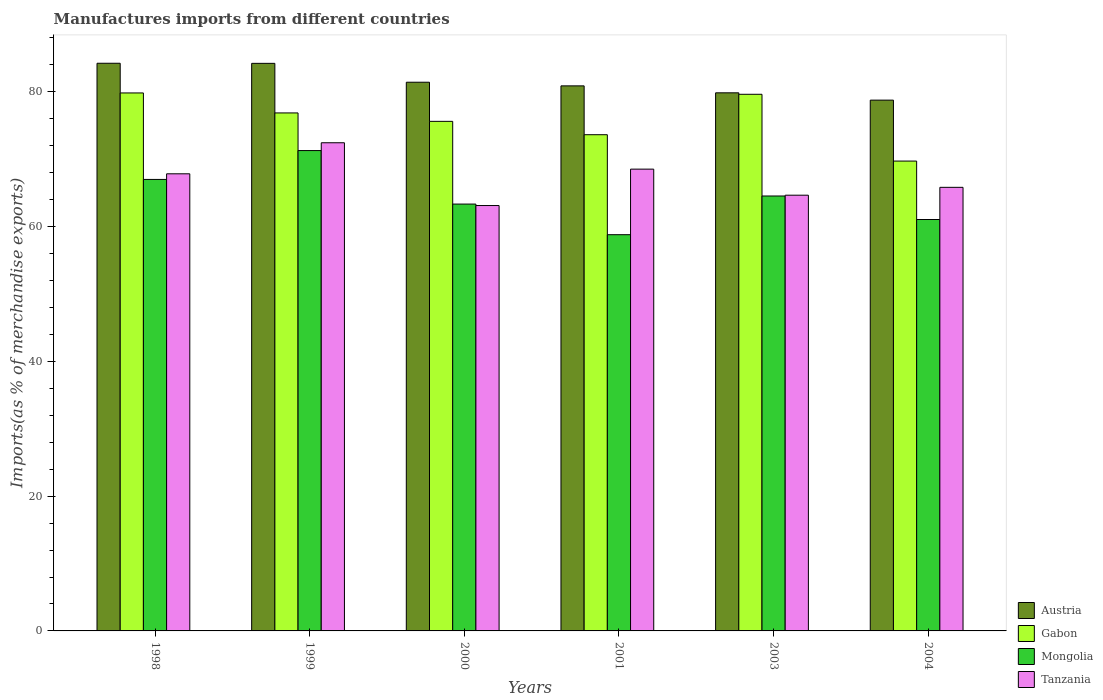How many groups of bars are there?
Give a very brief answer. 6. Are the number of bars on each tick of the X-axis equal?
Make the answer very short. Yes. How many bars are there on the 5th tick from the left?
Offer a very short reply. 4. In how many cases, is the number of bars for a given year not equal to the number of legend labels?
Ensure brevity in your answer.  0. What is the percentage of imports to different countries in Gabon in 2003?
Provide a short and direct response. 79.64. Across all years, what is the maximum percentage of imports to different countries in Austria?
Your response must be concise. 84.25. Across all years, what is the minimum percentage of imports to different countries in Austria?
Your answer should be very brief. 78.77. In which year was the percentage of imports to different countries in Mongolia maximum?
Your response must be concise. 1999. In which year was the percentage of imports to different countries in Austria minimum?
Give a very brief answer. 2004. What is the total percentage of imports to different countries in Mongolia in the graph?
Make the answer very short. 386.05. What is the difference between the percentage of imports to different countries in Mongolia in 2000 and that in 2003?
Offer a very short reply. -1.2. What is the difference between the percentage of imports to different countries in Gabon in 2000 and the percentage of imports to different countries in Mongolia in 2004?
Provide a succinct answer. 14.57. What is the average percentage of imports to different countries in Austria per year?
Your answer should be compact. 81.57. In the year 2000, what is the difference between the percentage of imports to different countries in Tanzania and percentage of imports to different countries in Gabon?
Your answer should be very brief. -12.5. In how many years, is the percentage of imports to different countries in Tanzania greater than 64 %?
Your answer should be compact. 5. What is the ratio of the percentage of imports to different countries in Tanzania in 1999 to that in 2001?
Offer a very short reply. 1.06. Is the difference between the percentage of imports to different countries in Tanzania in 1999 and 2001 greater than the difference between the percentage of imports to different countries in Gabon in 1999 and 2001?
Offer a very short reply. Yes. What is the difference between the highest and the second highest percentage of imports to different countries in Mongolia?
Offer a very short reply. 4.28. What is the difference between the highest and the lowest percentage of imports to different countries in Gabon?
Your answer should be compact. 10.11. In how many years, is the percentage of imports to different countries in Gabon greater than the average percentage of imports to different countries in Gabon taken over all years?
Make the answer very short. 3. What does the 3rd bar from the left in 1998 represents?
Your answer should be very brief. Mongolia. What does the 1st bar from the right in 1998 represents?
Offer a very short reply. Tanzania. How many bars are there?
Give a very brief answer. 24. Are all the bars in the graph horizontal?
Offer a very short reply. No. How many years are there in the graph?
Make the answer very short. 6. What is the difference between two consecutive major ticks on the Y-axis?
Offer a very short reply. 20. Are the values on the major ticks of Y-axis written in scientific E-notation?
Provide a succinct answer. No. Does the graph contain grids?
Offer a terse response. No. Where does the legend appear in the graph?
Ensure brevity in your answer.  Bottom right. What is the title of the graph?
Your response must be concise. Manufactures imports from different countries. Does "Latin America(developing only)" appear as one of the legend labels in the graph?
Provide a short and direct response. No. What is the label or title of the X-axis?
Your response must be concise. Years. What is the label or title of the Y-axis?
Provide a succinct answer. Imports(as % of merchandise exports). What is the Imports(as % of merchandise exports) in Austria in 1998?
Your response must be concise. 84.25. What is the Imports(as % of merchandise exports) in Gabon in 1998?
Your answer should be very brief. 79.84. What is the Imports(as % of merchandise exports) of Mongolia in 1998?
Ensure brevity in your answer.  67.01. What is the Imports(as % of merchandise exports) of Tanzania in 1998?
Make the answer very short. 67.84. What is the Imports(as % of merchandise exports) of Austria in 1999?
Your response must be concise. 84.23. What is the Imports(as % of merchandise exports) of Gabon in 1999?
Ensure brevity in your answer.  76.87. What is the Imports(as % of merchandise exports) in Mongolia in 1999?
Offer a terse response. 71.29. What is the Imports(as % of merchandise exports) in Tanzania in 1999?
Make the answer very short. 72.45. What is the Imports(as % of merchandise exports) of Austria in 2000?
Provide a succinct answer. 81.43. What is the Imports(as % of merchandise exports) of Gabon in 2000?
Your answer should be compact. 75.62. What is the Imports(as % of merchandise exports) in Mongolia in 2000?
Your answer should be very brief. 63.35. What is the Imports(as % of merchandise exports) of Tanzania in 2000?
Your answer should be compact. 63.13. What is the Imports(as % of merchandise exports) of Austria in 2001?
Make the answer very short. 80.89. What is the Imports(as % of merchandise exports) of Gabon in 2001?
Your answer should be very brief. 73.64. What is the Imports(as % of merchandise exports) of Mongolia in 2001?
Your response must be concise. 58.8. What is the Imports(as % of merchandise exports) of Tanzania in 2001?
Provide a short and direct response. 68.53. What is the Imports(as % of merchandise exports) of Austria in 2003?
Your response must be concise. 79.86. What is the Imports(as % of merchandise exports) of Gabon in 2003?
Provide a succinct answer. 79.64. What is the Imports(as % of merchandise exports) of Mongolia in 2003?
Your answer should be very brief. 64.55. What is the Imports(as % of merchandise exports) of Tanzania in 2003?
Ensure brevity in your answer.  64.66. What is the Imports(as % of merchandise exports) of Austria in 2004?
Keep it short and to the point. 78.77. What is the Imports(as % of merchandise exports) in Gabon in 2004?
Offer a very short reply. 69.73. What is the Imports(as % of merchandise exports) of Mongolia in 2004?
Ensure brevity in your answer.  61.06. What is the Imports(as % of merchandise exports) in Tanzania in 2004?
Your answer should be very brief. 65.83. Across all years, what is the maximum Imports(as % of merchandise exports) in Austria?
Your response must be concise. 84.25. Across all years, what is the maximum Imports(as % of merchandise exports) of Gabon?
Your answer should be very brief. 79.84. Across all years, what is the maximum Imports(as % of merchandise exports) in Mongolia?
Provide a succinct answer. 71.29. Across all years, what is the maximum Imports(as % of merchandise exports) in Tanzania?
Provide a succinct answer. 72.45. Across all years, what is the minimum Imports(as % of merchandise exports) in Austria?
Make the answer very short. 78.77. Across all years, what is the minimum Imports(as % of merchandise exports) of Gabon?
Offer a very short reply. 69.73. Across all years, what is the minimum Imports(as % of merchandise exports) of Mongolia?
Your response must be concise. 58.8. Across all years, what is the minimum Imports(as % of merchandise exports) of Tanzania?
Make the answer very short. 63.13. What is the total Imports(as % of merchandise exports) of Austria in the graph?
Provide a short and direct response. 489.43. What is the total Imports(as % of merchandise exports) of Gabon in the graph?
Provide a succinct answer. 455.35. What is the total Imports(as % of merchandise exports) in Mongolia in the graph?
Keep it short and to the point. 386.05. What is the total Imports(as % of merchandise exports) in Tanzania in the graph?
Provide a short and direct response. 402.45. What is the difference between the Imports(as % of merchandise exports) of Austria in 1998 and that in 1999?
Your answer should be compact. 0.01. What is the difference between the Imports(as % of merchandise exports) in Gabon in 1998 and that in 1999?
Your answer should be compact. 2.97. What is the difference between the Imports(as % of merchandise exports) in Mongolia in 1998 and that in 1999?
Your response must be concise. -4.28. What is the difference between the Imports(as % of merchandise exports) in Tanzania in 1998 and that in 1999?
Your response must be concise. -4.61. What is the difference between the Imports(as % of merchandise exports) in Austria in 1998 and that in 2000?
Provide a succinct answer. 2.81. What is the difference between the Imports(as % of merchandise exports) of Gabon in 1998 and that in 2000?
Ensure brevity in your answer.  4.22. What is the difference between the Imports(as % of merchandise exports) of Mongolia in 1998 and that in 2000?
Offer a terse response. 3.66. What is the difference between the Imports(as % of merchandise exports) of Tanzania in 1998 and that in 2000?
Offer a very short reply. 4.71. What is the difference between the Imports(as % of merchandise exports) in Austria in 1998 and that in 2001?
Your answer should be very brief. 3.36. What is the difference between the Imports(as % of merchandise exports) in Gabon in 1998 and that in 2001?
Offer a terse response. 6.2. What is the difference between the Imports(as % of merchandise exports) of Mongolia in 1998 and that in 2001?
Provide a short and direct response. 8.2. What is the difference between the Imports(as % of merchandise exports) in Tanzania in 1998 and that in 2001?
Provide a succinct answer. -0.69. What is the difference between the Imports(as % of merchandise exports) of Austria in 1998 and that in 2003?
Offer a very short reply. 4.39. What is the difference between the Imports(as % of merchandise exports) in Gabon in 1998 and that in 2003?
Your answer should be very brief. 0.2. What is the difference between the Imports(as % of merchandise exports) of Mongolia in 1998 and that in 2003?
Make the answer very short. 2.46. What is the difference between the Imports(as % of merchandise exports) in Tanzania in 1998 and that in 2003?
Ensure brevity in your answer.  3.18. What is the difference between the Imports(as % of merchandise exports) of Austria in 1998 and that in 2004?
Provide a succinct answer. 5.47. What is the difference between the Imports(as % of merchandise exports) in Gabon in 1998 and that in 2004?
Your answer should be compact. 10.11. What is the difference between the Imports(as % of merchandise exports) of Mongolia in 1998 and that in 2004?
Offer a terse response. 5.95. What is the difference between the Imports(as % of merchandise exports) in Tanzania in 1998 and that in 2004?
Offer a very short reply. 2.01. What is the difference between the Imports(as % of merchandise exports) in Austria in 1999 and that in 2000?
Give a very brief answer. 2.8. What is the difference between the Imports(as % of merchandise exports) in Gabon in 1999 and that in 2000?
Offer a very short reply. 1.25. What is the difference between the Imports(as % of merchandise exports) of Mongolia in 1999 and that in 2000?
Ensure brevity in your answer.  7.94. What is the difference between the Imports(as % of merchandise exports) in Tanzania in 1999 and that in 2000?
Keep it short and to the point. 9.32. What is the difference between the Imports(as % of merchandise exports) of Austria in 1999 and that in 2001?
Offer a terse response. 3.34. What is the difference between the Imports(as % of merchandise exports) in Gabon in 1999 and that in 2001?
Make the answer very short. 3.23. What is the difference between the Imports(as % of merchandise exports) in Mongolia in 1999 and that in 2001?
Your response must be concise. 12.48. What is the difference between the Imports(as % of merchandise exports) of Tanzania in 1999 and that in 2001?
Provide a succinct answer. 3.91. What is the difference between the Imports(as % of merchandise exports) in Austria in 1999 and that in 2003?
Give a very brief answer. 4.37. What is the difference between the Imports(as % of merchandise exports) in Gabon in 1999 and that in 2003?
Provide a short and direct response. -2.77. What is the difference between the Imports(as % of merchandise exports) in Mongolia in 1999 and that in 2003?
Offer a very short reply. 6.74. What is the difference between the Imports(as % of merchandise exports) in Tanzania in 1999 and that in 2003?
Your response must be concise. 7.78. What is the difference between the Imports(as % of merchandise exports) in Austria in 1999 and that in 2004?
Give a very brief answer. 5.46. What is the difference between the Imports(as % of merchandise exports) of Gabon in 1999 and that in 2004?
Provide a succinct answer. 7.14. What is the difference between the Imports(as % of merchandise exports) in Mongolia in 1999 and that in 2004?
Your response must be concise. 10.23. What is the difference between the Imports(as % of merchandise exports) of Tanzania in 1999 and that in 2004?
Your answer should be very brief. 6.62. What is the difference between the Imports(as % of merchandise exports) in Austria in 2000 and that in 2001?
Give a very brief answer. 0.54. What is the difference between the Imports(as % of merchandise exports) in Gabon in 2000 and that in 2001?
Ensure brevity in your answer.  1.98. What is the difference between the Imports(as % of merchandise exports) of Mongolia in 2000 and that in 2001?
Make the answer very short. 4.55. What is the difference between the Imports(as % of merchandise exports) in Tanzania in 2000 and that in 2001?
Provide a short and direct response. -5.4. What is the difference between the Imports(as % of merchandise exports) of Austria in 2000 and that in 2003?
Your answer should be compact. 1.57. What is the difference between the Imports(as % of merchandise exports) in Gabon in 2000 and that in 2003?
Ensure brevity in your answer.  -4.02. What is the difference between the Imports(as % of merchandise exports) of Mongolia in 2000 and that in 2003?
Give a very brief answer. -1.2. What is the difference between the Imports(as % of merchandise exports) of Tanzania in 2000 and that in 2003?
Your answer should be very brief. -1.54. What is the difference between the Imports(as % of merchandise exports) in Austria in 2000 and that in 2004?
Give a very brief answer. 2.66. What is the difference between the Imports(as % of merchandise exports) in Gabon in 2000 and that in 2004?
Provide a succinct answer. 5.89. What is the difference between the Imports(as % of merchandise exports) of Mongolia in 2000 and that in 2004?
Your answer should be very brief. 2.29. What is the difference between the Imports(as % of merchandise exports) of Tanzania in 2000 and that in 2004?
Make the answer very short. -2.7. What is the difference between the Imports(as % of merchandise exports) in Austria in 2001 and that in 2003?
Offer a terse response. 1.03. What is the difference between the Imports(as % of merchandise exports) in Gabon in 2001 and that in 2003?
Your answer should be compact. -6. What is the difference between the Imports(as % of merchandise exports) of Mongolia in 2001 and that in 2003?
Provide a succinct answer. -5.74. What is the difference between the Imports(as % of merchandise exports) of Tanzania in 2001 and that in 2003?
Your response must be concise. 3.87. What is the difference between the Imports(as % of merchandise exports) in Austria in 2001 and that in 2004?
Your answer should be compact. 2.12. What is the difference between the Imports(as % of merchandise exports) of Gabon in 2001 and that in 2004?
Your response must be concise. 3.91. What is the difference between the Imports(as % of merchandise exports) in Mongolia in 2001 and that in 2004?
Ensure brevity in your answer.  -2.25. What is the difference between the Imports(as % of merchandise exports) of Tanzania in 2001 and that in 2004?
Keep it short and to the point. 2.7. What is the difference between the Imports(as % of merchandise exports) in Austria in 2003 and that in 2004?
Your answer should be very brief. 1.08. What is the difference between the Imports(as % of merchandise exports) of Gabon in 2003 and that in 2004?
Make the answer very short. 9.91. What is the difference between the Imports(as % of merchandise exports) in Mongolia in 2003 and that in 2004?
Offer a very short reply. 3.49. What is the difference between the Imports(as % of merchandise exports) in Tanzania in 2003 and that in 2004?
Provide a short and direct response. -1.17. What is the difference between the Imports(as % of merchandise exports) of Austria in 1998 and the Imports(as % of merchandise exports) of Gabon in 1999?
Make the answer very short. 7.37. What is the difference between the Imports(as % of merchandise exports) in Austria in 1998 and the Imports(as % of merchandise exports) in Mongolia in 1999?
Offer a terse response. 12.96. What is the difference between the Imports(as % of merchandise exports) of Austria in 1998 and the Imports(as % of merchandise exports) of Tanzania in 1999?
Provide a short and direct response. 11.8. What is the difference between the Imports(as % of merchandise exports) in Gabon in 1998 and the Imports(as % of merchandise exports) in Mongolia in 1999?
Your answer should be compact. 8.55. What is the difference between the Imports(as % of merchandise exports) of Gabon in 1998 and the Imports(as % of merchandise exports) of Tanzania in 1999?
Give a very brief answer. 7.39. What is the difference between the Imports(as % of merchandise exports) of Mongolia in 1998 and the Imports(as % of merchandise exports) of Tanzania in 1999?
Make the answer very short. -5.44. What is the difference between the Imports(as % of merchandise exports) in Austria in 1998 and the Imports(as % of merchandise exports) in Gabon in 2000?
Keep it short and to the point. 8.62. What is the difference between the Imports(as % of merchandise exports) in Austria in 1998 and the Imports(as % of merchandise exports) in Mongolia in 2000?
Ensure brevity in your answer.  20.9. What is the difference between the Imports(as % of merchandise exports) of Austria in 1998 and the Imports(as % of merchandise exports) of Tanzania in 2000?
Provide a short and direct response. 21.12. What is the difference between the Imports(as % of merchandise exports) of Gabon in 1998 and the Imports(as % of merchandise exports) of Mongolia in 2000?
Your answer should be compact. 16.49. What is the difference between the Imports(as % of merchandise exports) in Gabon in 1998 and the Imports(as % of merchandise exports) in Tanzania in 2000?
Make the answer very short. 16.71. What is the difference between the Imports(as % of merchandise exports) in Mongolia in 1998 and the Imports(as % of merchandise exports) in Tanzania in 2000?
Offer a terse response. 3.88. What is the difference between the Imports(as % of merchandise exports) in Austria in 1998 and the Imports(as % of merchandise exports) in Gabon in 2001?
Give a very brief answer. 10.6. What is the difference between the Imports(as % of merchandise exports) in Austria in 1998 and the Imports(as % of merchandise exports) in Mongolia in 2001?
Give a very brief answer. 25.44. What is the difference between the Imports(as % of merchandise exports) of Austria in 1998 and the Imports(as % of merchandise exports) of Tanzania in 2001?
Ensure brevity in your answer.  15.71. What is the difference between the Imports(as % of merchandise exports) of Gabon in 1998 and the Imports(as % of merchandise exports) of Mongolia in 2001?
Give a very brief answer. 21.04. What is the difference between the Imports(as % of merchandise exports) of Gabon in 1998 and the Imports(as % of merchandise exports) of Tanzania in 2001?
Give a very brief answer. 11.31. What is the difference between the Imports(as % of merchandise exports) in Mongolia in 1998 and the Imports(as % of merchandise exports) in Tanzania in 2001?
Your answer should be very brief. -1.53. What is the difference between the Imports(as % of merchandise exports) of Austria in 1998 and the Imports(as % of merchandise exports) of Gabon in 2003?
Your answer should be compact. 4.61. What is the difference between the Imports(as % of merchandise exports) of Austria in 1998 and the Imports(as % of merchandise exports) of Mongolia in 2003?
Provide a succinct answer. 19.7. What is the difference between the Imports(as % of merchandise exports) in Austria in 1998 and the Imports(as % of merchandise exports) in Tanzania in 2003?
Ensure brevity in your answer.  19.58. What is the difference between the Imports(as % of merchandise exports) of Gabon in 1998 and the Imports(as % of merchandise exports) of Mongolia in 2003?
Make the answer very short. 15.29. What is the difference between the Imports(as % of merchandise exports) of Gabon in 1998 and the Imports(as % of merchandise exports) of Tanzania in 2003?
Provide a succinct answer. 15.18. What is the difference between the Imports(as % of merchandise exports) in Mongolia in 1998 and the Imports(as % of merchandise exports) in Tanzania in 2003?
Provide a short and direct response. 2.34. What is the difference between the Imports(as % of merchandise exports) in Austria in 1998 and the Imports(as % of merchandise exports) in Gabon in 2004?
Ensure brevity in your answer.  14.52. What is the difference between the Imports(as % of merchandise exports) in Austria in 1998 and the Imports(as % of merchandise exports) in Mongolia in 2004?
Offer a terse response. 23.19. What is the difference between the Imports(as % of merchandise exports) in Austria in 1998 and the Imports(as % of merchandise exports) in Tanzania in 2004?
Keep it short and to the point. 18.41. What is the difference between the Imports(as % of merchandise exports) of Gabon in 1998 and the Imports(as % of merchandise exports) of Mongolia in 2004?
Your answer should be compact. 18.79. What is the difference between the Imports(as % of merchandise exports) of Gabon in 1998 and the Imports(as % of merchandise exports) of Tanzania in 2004?
Offer a terse response. 14.01. What is the difference between the Imports(as % of merchandise exports) of Mongolia in 1998 and the Imports(as % of merchandise exports) of Tanzania in 2004?
Your response must be concise. 1.17. What is the difference between the Imports(as % of merchandise exports) in Austria in 1999 and the Imports(as % of merchandise exports) in Gabon in 2000?
Offer a terse response. 8.61. What is the difference between the Imports(as % of merchandise exports) of Austria in 1999 and the Imports(as % of merchandise exports) of Mongolia in 2000?
Keep it short and to the point. 20.88. What is the difference between the Imports(as % of merchandise exports) of Austria in 1999 and the Imports(as % of merchandise exports) of Tanzania in 2000?
Make the answer very short. 21.1. What is the difference between the Imports(as % of merchandise exports) of Gabon in 1999 and the Imports(as % of merchandise exports) of Mongolia in 2000?
Your answer should be very brief. 13.52. What is the difference between the Imports(as % of merchandise exports) of Gabon in 1999 and the Imports(as % of merchandise exports) of Tanzania in 2000?
Your answer should be compact. 13.74. What is the difference between the Imports(as % of merchandise exports) in Mongolia in 1999 and the Imports(as % of merchandise exports) in Tanzania in 2000?
Your response must be concise. 8.16. What is the difference between the Imports(as % of merchandise exports) of Austria in 1999 and the Imports(as % of merchandise exports) of Gabon in 2001?
Ensure brevity in your answer.  10.59. What is the difference between the Imports(as % of merchandise exports) of Austria in 1999 and the Imports(as % of merchandise exports) of Mongolia in 2001?
Give a very brief answer. 25.43. What is the difference between the Imports(as % of merchandise exports) in Austria in 1999 and the Imports(as % of merchandise exports) in Tanzania in 2001?
Make the answer very short. 15.7. What is the difference between the Imports(as % of merchandise exports) of Gabon in 1999 and the Imports(as % of merchandise exports) of Mongolia in 2001?
Your answer should be compact. 18.07. What is the difference between the Imports(as % of merchandise exports) of Gabon in 1999 and the Imports(as % of merchandise exports) of Tanzania in 2001?
Give a very brief answer. 8.34. What is the difference between the Imports(as % of merchandise exports) of Mongolia in 1999 and the Imports(as % of merchandise exports) of Tanzania in 2001?
Your answer should be very brief. 2.75. What is the difference between the Imports(as % of merchandise exports) of Austria in 1999 and the Imports(as % of merchandise exports) of Gabon in 2003?
Your response must be concise. 4.59. What is the difference between the Imports(as % of merchandise exports) of Austria in 1999 and the Imports(as % of merchandise exports) of Mongolia in 2003?
Provide a short and direct response. 19.68. What is the difference between the Imports(as % of merchandise exports) of Austria in 1999 and the Imports(as % of merchandise exports) of Tanzania in 2003?
Provide a short and direct response. 19.57. What is the difference between the Imports(as % of merchandise exports) in Gabon in 1999 and the Imports(as % of merchandise exports) in Mongolia in 2003?
Offer a very short reply. 12.33. What is the difference between the Imports(as % of merchandise exports) of Gabon in 1999 and the Imports(as % of merchandise exports) of Tanzania in 2003?
Make the answer very short. 12.21. What is the difference between the Imports(as % of merchandise exports) of Mongolia in 1999 and the Imports(as % of merchandise exports) of Tanzania in 2003?
Make the answer very short. 6.62. What is the difference between the Imports(as % of merchandise exports) of Austria in 1999 and the Imports(as % of merchandise exports) of Gabon in 2004?
Offer a terse response. 14.5. What is the difference between the Imports(as % of merchandise exports) of Austria in 1999 and the Imports(as % of merchandise exports) of Mongolia in 2004?
Offer a terse response. 23.18. What is the difference between the Imports(as % of merchandise exports) of Austria in 1999 and the Imports(as % of merchandise exports) of Tanzania in 2004?
Your response must be concise. 18.4. What is the difference between the Imports(as % of merchandise exports) of Gabon in 1999 and the Imports(as % of merchandise exports) of Mongolia in 2004?
Your answer should be compact. 15.82. What is the difference between the Imports(as % of merchandise exports) in Gabon in 1999 and the Imports(as % of merchandise exports) in Tanzania in 2004?
Give a very brief answer. 11.04. What is the difference between the Imports(as % of merchandise exports) in Mongolia in 1999 and the Imports(as % of merchandise exports) in Tanzania in 2004?
Your response must be concise. 5.46. What is the difference between the Imports(as % of merchandise exports) in Austria in 2000 and the Imports(as % of merchandise exports) in Gabon in 2001?
Provide a succinct answer. 7.79. What is the difference between the Imports(as % of merchandise exports) of Austria in 2000 and the Imports(as % of merchandise exports) of Mongolia in 2001?
Provide a succinct answer. 22.63. What is the difference between the Imports(as % of merchandise exports) of Austria in 2000 and the Imports(as % of merchandise exports) of Tanzania in 2001?
Ensure brevity in your answer.  12.9. What is the difference between the Imports(as % of merchandise exports) in Gabon in 2000 and the Imports(as % of merchandise exports) in Mongolia in 2001?
Your answer should be very brief. 16.82. What is the difference between the Imports(as % of merchandise exports) in Gabon in 2000 and the Imports(as % of merchandise exports) in Tanzania in 2001?
Your answer should be very brief. 7.09. What is the difference between the Imports(as % of merchandise exports) in Mongolia in 2000 and the Imports(as % of merchandise exports) in Tanzania in 2001?
Ensure brevity in your answer.  -5.18. What is the difference between the Imports(as % of merchandise exports) of Austria in 2000 and the Imports(as % of merchandise exports) of Gabon in 2003?
Provide a succinct answer. 1.79. What is the difference between the Imports(as % of merchandise exports) of Austria in 2000 and the Imports(as % of merchandise exports) of Mongolia in 2003?
Your response must be concise. 16.88. What is the difference between the Imports(as % of merchandise exports) in Austria in 2000 and the Imports(as % of merchandise exports) in Tanzania in 2003?
Keep it short and to the point. 16.77. What is the difference between the Imports(as % of merchandise exports) of Gabon in 2000 and the Imports(as % of merchandise exports) of Mongolia in 2003?
Provide a succinct answer. 11.08. What is the difference between the Imports(as % of merchandise exports) of Gabon in 2000 and the Imports(as % of merchandise exports) of Tanzania in 2003?
Keep it short and to the point. 10.96. What is the difference between the Imports(as % of merchandise exports) in Mongolia in 2000 and the Imports(as % of merchandise exports) in Tanzania in 2003?
Make the answer very short. -1.32. What is the difference between the Imports(as % of merchandise exports) in Austria in 2000 and the Imports(as % of merchandise exports) in Gabon in 2004?
Provide a succinct answer. 11.7. What is the difference between the Imports(as % of merchandise exports) of Austria in 2000 and the Imports(as % of merchandise exports) of Mongolia in 2004?
Provide a short and direct response. 20.38. What is the difference between the Imports(as % of merchandise exports) of Austria in 2000 and the Imports(as % of merchandise exports) of Tanzania in 2004?
Offer a very short reply. 15.6. What is the difference between the Imports(as % of merchandise exports) in Gabon in 2000 and the Imports(as % of merchandise exports) in Mongolia in 2004?
Your answer should be compact. 14.57. What is the difference between the Imports(as % of merchandise exports) of Gabon in 2000 and the Imports(as % of merchandise exports) of Tanzania in 2004?
Provide a succinct answer. 9.79. What is the difference between the Imports(as % of merchandise exports) in Mongolia in 2000 and the Imports(as % of merchandise exports) in Tanzania in 2004?
Your answer should be compact. -2.48. What is the difference between the Imports(as % of merchandise exports) in Austria in 2001 and the Imports(as % of merchandise exports) in Gabon in 2003?
Your answer should be compact. 1.25. What is the difference between the Imports(as % of merchandise exports) of Austria in 2001 and the Imports(as % of merchandise exports) of Mongolia in 2003?
Make the answer very short. 16.34. What is the difference between the Imports(as % of merchandise exports) of Austria in 2001 and the Imports(as % of merchandise exports) of Tanzania in 2003?
Provide a succinct answer. 16.23. What is the difference between the Imports(as % of merchandise exports) in Gabon in 2001 and the Imports(as % of merchandise exports) in Mongolia in 2003?
Provide a succinct answer. 9.1. What is the difference between the Imports(as % of merchandise exports) of Gabon in 2001 and the Imports(as % of merchandise exports) of Tanzania in 2003?
Offer a terse response. 8.98. What is the difference between the Imports(as % of merchandise exports) in Mongolia in 2001 and the Imports(as % of merchandise exports) in Tanzania in 2003?
Your answer should be compact. -5.86. What is the difference between the Imports(as % of merchandise exports) in Austria in 2001 and the Imports(as % of merchandise exports) in Gabon in 2004?
Provide a short and direct response. 11.16. What is the difference between the Imports(as % of merchandise exports) in Austria in 2001 and the Imports(as % of merchandise exports) in Mongolia in 2004?
Your answer should be very brief. 19.83. What is the difference between the Imports(as % of merchandise exports) of Austria in 2001 and the Imports(as % of merchandise exports) of Tanzania in 2004?
Ensure brevity in your answer.  15.06. What is the difference between the Imports(as % of merchandise exports) in Gabon in 2001 and the Imports(as % of merchandise exports) in Mongolia in 2004?
Your answer should be very brief. 12.59. What is the difference between the Imports(as % of merchandise exports) of Gabon in 2001 and the Imports(as % of merchandise exports) of Tanzania in 2004?
Make the answer very short. 7.81. What is the difference between the Imports(as % of merchandise exports) of Mongolia in 2001 and the Imports(as % of merchandise exports) of Tanzania in 2004?
Your answer should be very brief. -7.03. What is the difference between the Imports(as % of merchandise exports) in Austria in 2003 and the Imports(as % of merchandise exports) in Gabon in 2004?
Give a very brief answer. 10.13. What is the difference between the Imports(as % of merchandise exports) of Austria in 2003 and the Imports(as % of merchandise exports) of Mongolia in 2004?
Your response must be concise. 18.8. What is the difference between the Imports(as % of merchandise exports) in Austria in 2003 and the Imports(as % of merchandise exports) in Tanzania in 2004?
Offer a terse response. 14.03. What is the difference between the Imports(as % of merchandise exports) of Gabon in 2003 and the Imports(as % of merchandise exports) of Mongolia in 2004?
Give a very brief answer. 18.58. What is the difference between the Imports(as % of merchandise exports) in Gabon in 2003 and the Imports(as % of merchandise exports) in Tanzania in 2004?
Ensure brevity in your answer.  13.81. What is the difference between the Imports(as % of merchandise exports) of Mongolia in 2003 and the Imports(as % of merchandise exports) of Tanzania in 2004?
Keep it short and to the point. -1.29. What is the average Imports(as % of merchandise exports) in Austria per year?
Your answer should be very brief. 81.57. What is the average Imports(as % of merchandise exports) of Gabon per year?
Offer a terse response. 75.89. What is the average Imports(as % of merchandise exports) in Mongolia per year?
Make the answer very short. 64.34. What is the average Imports(as % of merchandise exports) of Tanzania per year?
Provide a succinct answer. 67.08. In the year 1998, what is the difference between the Imports(as % of merchandise exports) in Austria and Imports(as % of merchandise exports) in Gabon?
Your answer should be very brief. 4.4. In the year 1998, what is the difference between the Imports(as % of merchandise exports) of Austria and Imports(as % of merchandise exports) of Mongolia?
Ensure brevity in your answer.  17.24. In the year 1998, what is the difference between the Imports(as % of merchandise exports) in Austria and Imports(as % of merchandise exports) in Tanzania?
Your response must be concise. 16.41. In the year 1998, what is the difference between the Imports(as % of merchandise exports) of Gabon and Imports(as % of merchandise exports) of Mongolia?
Your answer should be compact. 12.84. In the year 1998, what is the difference between the Imports(as % of merchandise exports) of Gabon and Imports(as % of merchandise exports) of Tanzania?
Make the answer very short. 12. In the year 1998, what is the difference between the Imports(as % of merchandise exports) of Mongolia and Imports(as % of merchandise exports) of Tanzania?
Your answer should be compact. -0.84. In the year 1999, what is the difference between the Imports(as % of merchandise exports) in Austria and Imports(as % of merchandise exports) in Gabon?
Provide a short and direct response. 7.36. In the year 1999, what is the difference between the Imports(as % of merchandise exports) in Austria and Imports(as % of merchandise exports) in Mongolia?
Provide a short and direct response. 12.94. In the year 1999, what is the difference between the Imports(as % of merchandise exports) of Austria and Imports(as % of merchandise exports) of Tanzania?
Your answer should be compact. 11.78. In the year 1999, what is the difference between the Imports(as % of merchandise exports) in Gabon and Imports(as % of merchandise exports) in Mongolia?
Ensure brevity in your answer.  5.59. In the year 1999, what is the difference between the Imports(as % of merchandise exports) of Gabon and Imports(as % of merchandise exports) of Tanzania?
Provide a short and direct response. 4.43. In the year 1999, what is the difference between the Imports(as % of merchandise exports) in Mongolia and Imports(as % of merchandise exports) in Tanzania?
Keep it short and to the point. -1.16. In the year 2000, what is the difference between the Imports(as % of merchandise exports) in Austria and Imports(as % of merchandise exports) in Gabon?
Provide a short and direct response. 5.81. In the year 2000, what is the difference between the Imports(as % of merchandise exports) of Austria and Imports(as % of merchandise exports) of Mongolia?
Give a very brief answer. 18.08. In the year 2000, what is the difference between the Imports(as % of merchandise exports) of Austria and Imports(as % of merchandise exports) of Tanzania?
Make the answer very short. 18.3. In the year 2000, what is the difference between the Imports(as % of merchandise exports) of Gabon and Imports(as % of merchandise exports) of Mongolia?
Provide a succinct answer. 12.28. In the year 2000, what is the difference between the Imports(as % of merchandise exports) in Gabon and Imports(as % of merchandise exports) in Tanzania?
Ensure brevity in your answer.  12.5. In the year 2000, what is the difference between the Imports(as % of merchandise exports) of Mongolia and Imports(as % of merchandise exports) of Tanzania?
Your response must be concise. 0.22. In the year 2001, what is the difference between the Imports(as % of merchandise exports) of Austria and Imports(as % of merchandise exports) of Gabon?
Provide a short and direct response. 7.25. In the year 2001, what is the difference between the Imports(as % of merchandise exports) in Austria and Imports(as % of merchandise exports) in Mongolia?
Provide a succinct answer. 22.09. In the year 2001, what is the difference between the Imports(as % of merchandise exports) in Austria and Imports(as % of merchandise exports) in Tanzania?
Your response must be concise. 12.36. In the year 2001, what is the difference between the Imports(as % of merchandise exports) in Gabon and Imports(as % of merchandise exports) in Mongolia?
Your response must be concise. 14.84. In the year 2001, what is the difference between the Imports(as % of merchandise exports) of Gabon and Imports(as % of merchandise exports) of Tanzania?
Offer a terse response. 5.11. In the year 2001, what is the difference between the Imports(as % of merchandise exports) in Mongolia and Imports(as % of merchandise exports) in Tanzania?
Provide a succinct answer. -9.73. In the year 2003, what is the difference between the Imports(as % of merchandise exports) of Austria and Imports(as % of merchandise exports) of Gabon?
Provide a succinct answer. 0.22. In the year 2003, what is the difference between the Imports(as % of merchandise exports) of Austria and Imports(as % of merchandise exports) of Mongolia?
Your response must be concise. 15.31. In the year 2003, what is the difference between the Imports(as % of merchandise exports) of Austria and Imports(as % of merchandise exports) of Tanzania?
Provide a succinct answer. 15.19. In the year 2003, what is the difference between the Imports(as % of merchandise exports) in Gabon and Imports(as % of merchandise exports) in Mongolia?
Make the answer very short. 15.09. In the year 2003, what is the difference between the Imports(as % of merchandise exports) of Gabon and Imports(as % of merchandise exports) of Tanzania?
Keep it short and to the point. 14.98. In the year 2003, what is the difference between the Imports(as % of merchandise exports) in Mongolia and Imports(as % of merchandise exports) in Tanzania?
Make the answer very short. -0.12. In the year 2004, what is the difference between the Imports(as % of merchandise exports) of Austria and Imports(as % of merchandise exports) of Gabon?
Keep it short and to the point. 9.04. In the year 2004, what is the difference between the Imports(as % of merchandise exports) in Austria and Imports(as % of merchandise exports) in Mongolia?
Give a very brief answer. 17.72. In the year 2004, what is the difference between the Imports(as % of merchandise exports) of Austria and Imports(as % of merchandise exports) of Tanzania?
Provide a short and direct response. 12.94. In the year 2004, what is the difference between the Imports(as % of merchandise exports) in Gabon and Imports(as % of merchandise exports) in Mongolia?
Make the answer very short. 8.67. In the year 2004, what is the difference between the Imports(as % of merchandise exports) of Gabon and Imports(as % of merchandise exports) of Tanzania?
Your answer should be compact. 3.9. In the year 2004, what is the difference between the Imports(as % of merchandise exports) in Mongolia and Imports(as % of merchandise exports) in Tanzania?
Ensure brevity in your answer.  -4.78. What is the ratio of the Imports(as % of merchandise exports) of Austria in 1998 to that in 1999?
Make the answer very short. 1. What is the ratio of the Imports(as % of merchandise exports) of Gabon in 1998 to that in 1999?
Your response must be concise. 1.04. What is the ratio of the Imports(as % of merchandise exports) in Mongolia in 1998 to that in 1999?
Provide a succinct answer. 0.94. What is the ratio of the Imports(as % of merchandise exports) in Tanzania in 1998 to that in 1999?
Make the answer very short. 0.94. What is the ratio of the Imports(as % of merchandise exports) of Austria in 1998 to that in 2000?
Ensure brevity in your answer.  1.03. What is the ratio of the Imports(as % of merchandise exports) in Gabon in 1998 to that in 2000?
Your response must be concise. 1.06. What is the ratio of the Imports(as % of merchandise exports) in Mongolia in 1998 to that in 2000?
Offer a terse response. 1.06. What is the ratio of the Imports(as % of merchandise exports) of Tanzania in 1998 to that in 2000?
Make the answer very short. 1.07. What is the ratio of the Imports(as % of merchandise exports) of Austria in 1998 to that in 2001?
Your answer should be compact. 1.04. What is the ratio of the Imports(as % of merchandise exports) of Gabon in 1998 to that in 2001?
Provide a succinct answer. 1.08. What is the ratio of the Imports(as % of merchandise exports) of Mongolia in 1998 to that in 2001?
Your response must be concise. 1.14. What is the ratio of the Imports(as % of merchandise exports) of Austria in 1998 to that in 2003?
Your answer should be compact. 1.05. What is the ratio of the Imports(as % of merchandise exports) of Gabon in 1998 to that in 2003?
Offer a very short reply. 1. What is the ratio of the Imports(as % of merchandise exports) in Mongolia in 1998 to that in 2003?
Provide a succinct answer. 1.04. What is the ratio of the Imports(as % of merchandise exports) of Tanzania in 1998 to that in 2003?
Make the answer very short. 1.05. What is the ratio of the Imports(as % of merchandise exports) of Austria in 1998 to that in 2004?
Provide a succinct answer. 1.07. What is the ratio of the Imports(as % of merchandise exports) in Gabon in 1998 to that in 2004?
Ensure brevity in your answer.  1.15. What is the ratio of the Imports(as % of merchandise exports) of Mongolia in 1998 to that in 2004?
Provide a short and direct response. 1.1. What is the ratio of the Imports(as % of merchandise exports) in Tanzania in 1998 to that in 2004?
Offer a terse response. 1.03. What is the ratio of the Imports(as % of merchandise exports) of Austria in 1999 to that in 2000?
Ensure brevity in your answer.  1.03. What is the ratio of the Imports(as % of merchandise exports) in Gabon in 1999 to that in 2000?
Give a very brief answer. 1.02. What is the ratio of the Imports(as % of merchandise exports) of Mongolia in 1999 to that in 2000?
Your response must be concise. 1.13. What is the ratio of the Imports(as % of merchandise exports) in Tanzania in 1999 to that in 2000?
Your answer should be compact. 1.15. What is the ratio of the Imports(as % of merchandise exports) in Austria in 1999 to that in 2001?
Your answer should be compact. 1.04. What is the ratio of the Imports(as % of merchandise exports) in Gabon in 1999 to that in 2001?
Provide a short and direct response. 1.04. What is the ratio of the Imports(as % of merchandise exports) of Mongolia in 1999 to that in 2001?
Ensure brevity in your answer.  1.21. What is the ratio of the Imports(as % of merchandise exports) in Tanzania in 1999 to that in 2001?
Provide a short and direct response. 1.06. What is the ratio of the Imports(as % of merchandise exports) of Austria in 1999 to that in 2003?
Your answer should be compact. 1.05. What is the ratio of the Imports(as % of merchandise exports) in Gabon in 1999 to that in 2003?
Offer a very short reply. 0.97. What is the ratio of the Imports(as % of merchandise exports) in Mongolia in 1999 to that in 2003?
Your response must be concise. 1.1. What is the ratio of the Imports(as % of merchandise exports) of Tanzania in 1999 to that in 2003?
Offer a terse response. 1.12. What is the ratio of the Imports(as % of merchandise exports) of Austria in 1999 to that in 2004?
Offer a terse response. 1.07. What is the ratio of the Imports(as % of merchandise exports) of Gabon in 1999 to that in 2004?
Offer a very short reply. 1.1. What is the ratio of the Imports(as % of merchandise exports) in Mongolia in 1999 to that in 2004?
Keep it short and to the point. 1.17. What is the ratio of the Imports(as % of merchandise exports) of Tanzania in 1999 to that in 2004?
Give a very brief answer. 1.1. What is the ratio of the Imports(as % of merchandise exports) of Gabon in 2000 to that in 2001?
Ensure brevity in your answer.  1.03. What is the ratio of the Imports(as % of merchandise exports) of Mongolia in 2000 to that in 2001?
Your response must be concise. 1.08. What is the ratio of the Imports(as % of merchandise exports) in Tanzania in 2000 to that in 2001?
Offer a very short reply. 0.92. What is the ratio of the Imports(as % of merchandise exports) in Austria in 2000 to that in 2003?
Offer a very short reply. 1.02. What is the ratio of the Imports(as % of merchandise exports) in Gabon in 2000 to that in 2003?
Your answer should be very brief. 0.95. What is the ratio of the Imports(as % of merchandise exports) of Mongolia in 2000 to that in 2003?
Offer a terse response. 0.98. What is the ratio of the Imports(as % of merchandise exports) of Tanzania in 2000 to that in 2003?
Your answer should be compact. 0.98. What is the ratio of the Imports(as % of merchandise exports) of Austria in 2000 to that in 2004?
Provide a succinct answer. 1.03. What is the ratio of the Imports(as % of merchandise exports) in Gabon in 2000 to that in 2004?
Offer a very short reply. 1.08. What is the ratio of the Imports(as % of merchandise exports) of Mongolia in 2000 to that in 2004?
Provide a short and direct response. 1.04. What is the ratio of the Imports(as % of merchandise exports) in Tanzania in 2000 to that in 2004?
Ensure brevity in your answer.  0.96. What is the ratio of the Imports(as % of merchandise exports) in Austria in 2001 to that in 2003?
Make the answer very short. 1.01. What is the ratio of the Imports(as % of merchandise exports) in Gabon in 2001 to that in 2003?
Give a very brief answer. 0.92. What is the ratio of the Imports(as % of merchandise exports) of Mongolia in 2001 to that in 2003?
Make the answer very short. 0.91. What is the ratio of the Imports(as % of merchandise exports) of Tanzania in 2001 to that in 2003?
Give a very brief answer. 1.06. What is the ratio of the Imports(as % of merchandise exports) of Austria in 2001 to that in 2004?
Make the answer very short. 1.03. What is the ratio of the Imports(as % of merchandise exports) of Gabon in 2001 to that in 2004?
Give a very brief answer. 1.06. What is the ratio of the Imports(as % of merchandise exports) in Mongolia in 2001 to that in 2004?
Offer a terse response. 0.96. What is the ratio of the Imports(as % of merchandise exports) of Tanzania in 2001 to that in 2004?
Your response must be concise. 1.04. What is the ratio of the Imports(as % of merchandise exports) in Austria in 2003 to that in 2004?
Provide a short and direct response. 1.01. What is the ratio of the Imports(as % of merchandise exports) in Gabon in 2003 to that in 2004?
Offer a very short reply. 1.14. What is the ratio of the Imports(as % of merchandise exports) of Mongolia in 2003 to that in 2004?
Your answer should be compact. 1.06. What is the ratio of the Imports(as % of merchandise exports) of Tanzania in 2003 to that in 2004?
Your response must be concise. 0.98. What is the difference between the highest and the second highest Imports(as % of merchandise exports) of Austria?
Ensure brevity in your answer.  0.01. What is the difference between the highest and the second highest Imports(as % of merchandise exports) of Gabon?
Offer a very short reply. 0.2. What is the difference between the highest and the second highest Imports(as % of merchandise exports) of Mongolia?
Offer a very short reply. 4.28. What is the difference between the highest and the second highest Imports(as % of merchandise exports) of Tanzania?
Give a very brief answer. 3.91. What is the difference between the highest and the lowest Imports(as % of merchandise exports) of Austria?
Provide a short and direct response. 5.47. What is the difference between the highest and the lowest Imports(as % of merchandise exports) of Gabon?
Your response must be concise. 10.11. What is the difference between the highest and the lowest Imports(as % of merchandise exports) in Mongolia?
Your response must be concise. 12.48. What is the difference between the highest and the lowest Imports(as % of merchandise exports) of Tanzania?
Your answer should be compact. 9.32. 